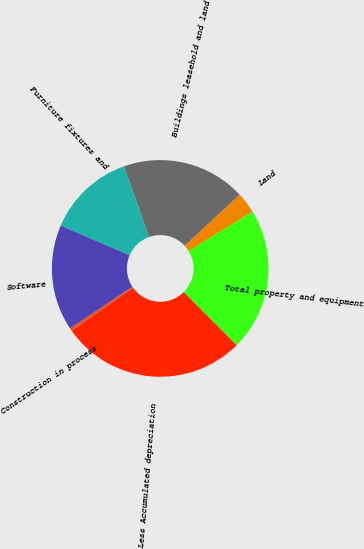Convert chart to OTSL. <chart><loc_0><loc_0><loc_500><loc_500><pie_chart><fcel>Land<fcel>Buildings leasehold and land<fcel>Furniture fixtures and<fcel>Software<fcel>Construction in process<fcel>Less Accumulated depreciation<fcel>Total property and equipment<nl><fcel>3.16%<fcel>18.54%<fcel>13.09%<fcel>15.81%<fcel>0.43%<fcel>27.7%<fcel>21.27%<nl></chart> 